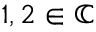<formula> <loc_0><loc_0><loc_500><loc_500>1 , 2 \in \mathbb { C }</formula> 